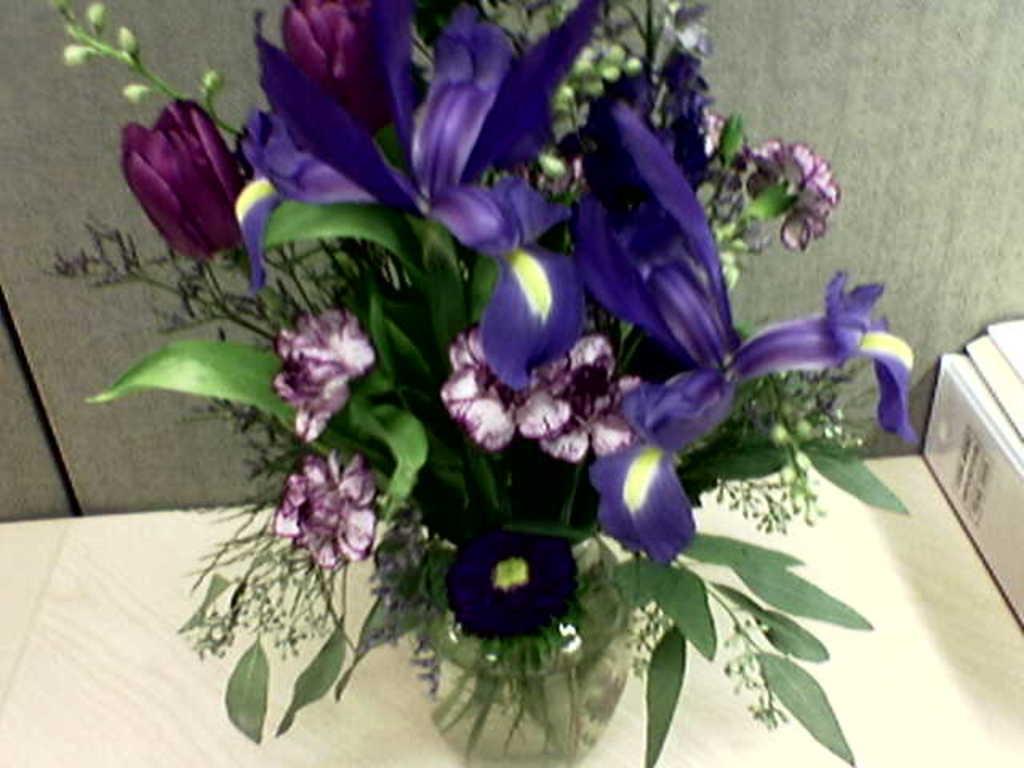In one or two sentences, can you explain what this image depicts? In this image there is a table and we can see a flower vase containing leaves and flowers placed on the table. In the background there is a wall. 